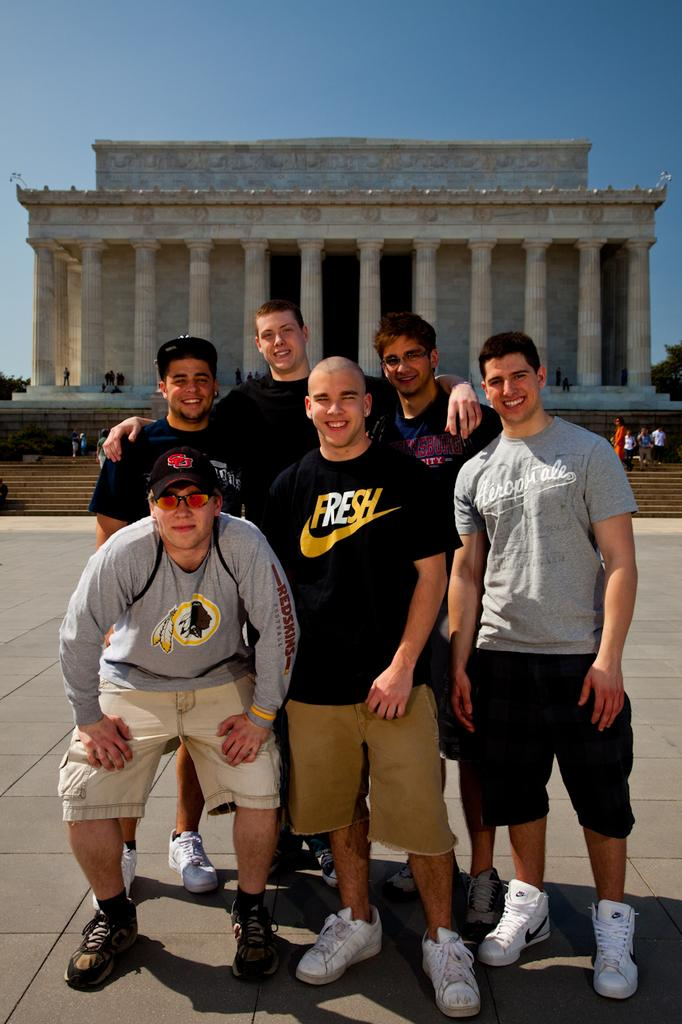<image>
Describe the image concisely. A group of men, one wearing a FRESH shirt and another wearing an Aeropostale shirt,  pose for a photo in front of a building with many columns. 